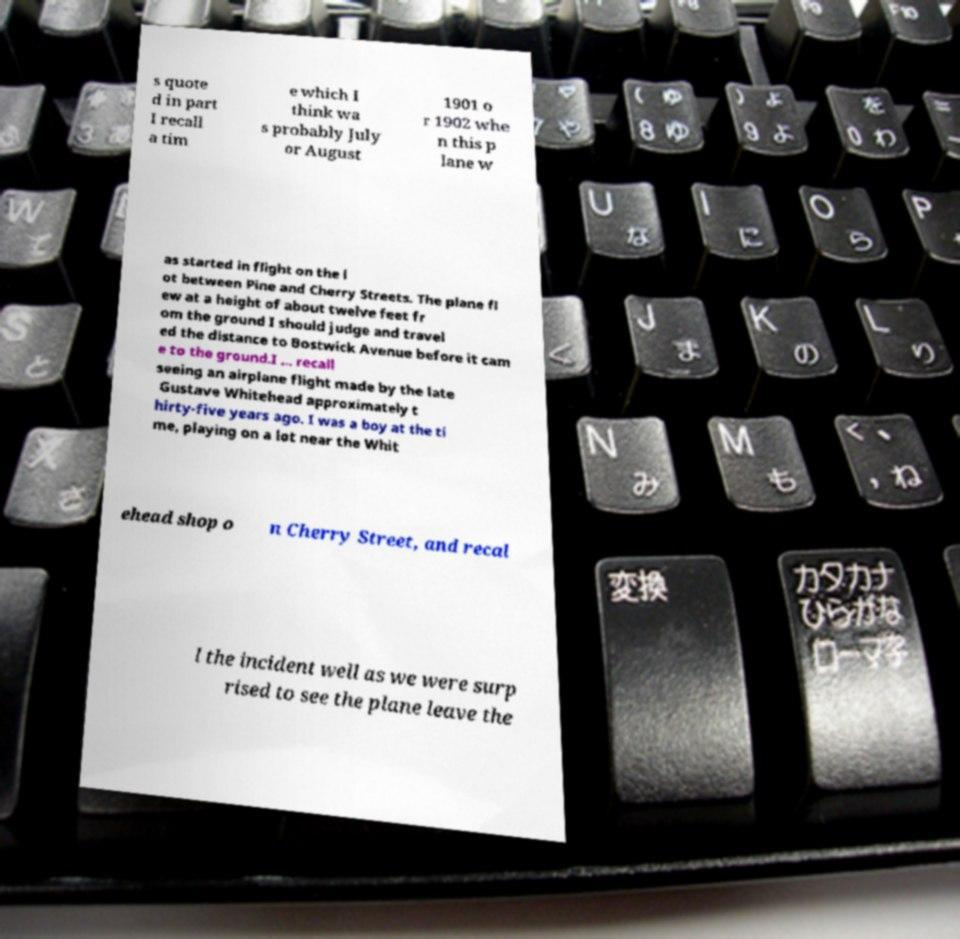There's text embedded in this image that I need extracted. Can you transcribe it verbatim? s quote d in part I recall a tim e which I think wa s probably July or August 1901 o r 1902 whe n this p lane w as started in flight on the l ot between Pine and Cherry Streets. The plane fl ew at a height of about twelve feet fr om the ground I should judge and travel ed the distance to Bostwick Avenue before it cam e to the ground.I ... recall seeing an airplane flight made by the late Gustave Whitehead approximately t hirty-five years ago. I was a boy at the ti me, playing on a lot near the Whit ehead shop o n Cherry Street, and recal l the incident well as we were surp rised to see the plane leave the 